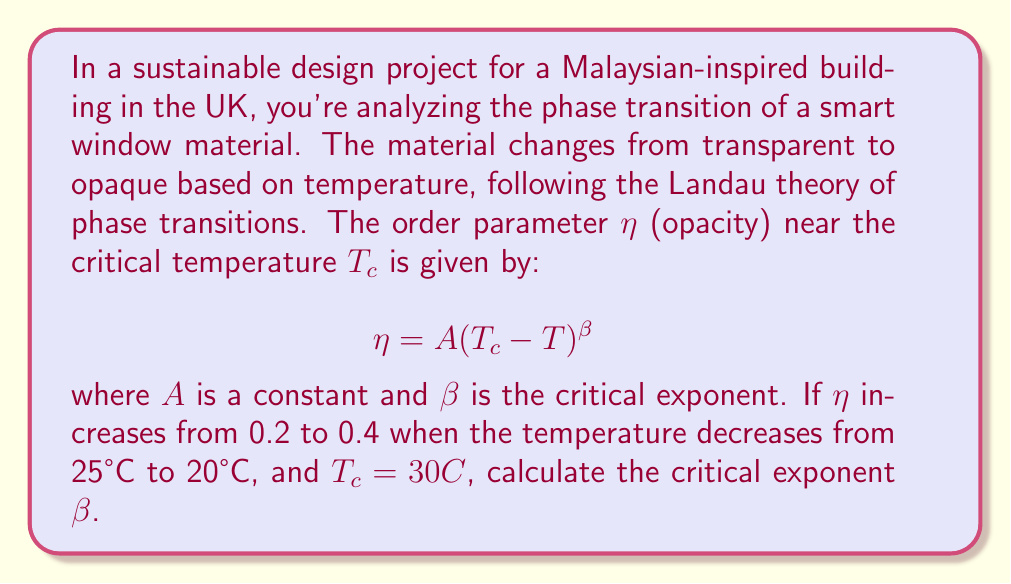Help me with this question. Let's approach this step-by-step:

1) We have two data points:
   At $T_1 = 25°C$, $\eta_1 = 0.2$
   At $T_2 = 20°C$, $\eta_2 = 0.4$

2) We can write two equations using the given formula:
   $$0.2 = A(30 - 25)^\beta$$
   $$0.4 = A(30 - 20)^\beta$$

3) Dividing the second equation by the first:
   $$\frac{0.4}{0.2} = \frac{A(30 - 20)^\beta}{A(30 - 25)^\beta}$$

4) The $A$ cancels out:
   $$2 = \frac{10^\beta}{5^\beta}$$

5) This can be rewritten as:
   $$2 = 2^\beta$$

6) Taking the logarithm of both sides:
   $$\log_2(2) = \log_2(2^\beta)$$

7) The left side simplifies to 1, and the right side becomes $\beta$:
   $$1 = \beta$$

Therefore, the critical exponent $\beta$ is equal to 1.
Answer: $\beta = 1$ 